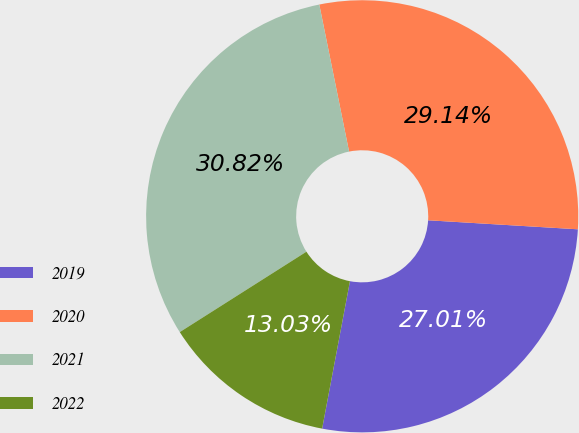Convert chart. <chart><loc_0><loc_0><loc_500><loc_500><pie_chart><fcel>2019<fcel>2020<fcel>2021<fcel>2022<nl><fcel>27.01%<fcel>29.14%<fcel>30.82%<fcel>13.03%<nl></chart> 